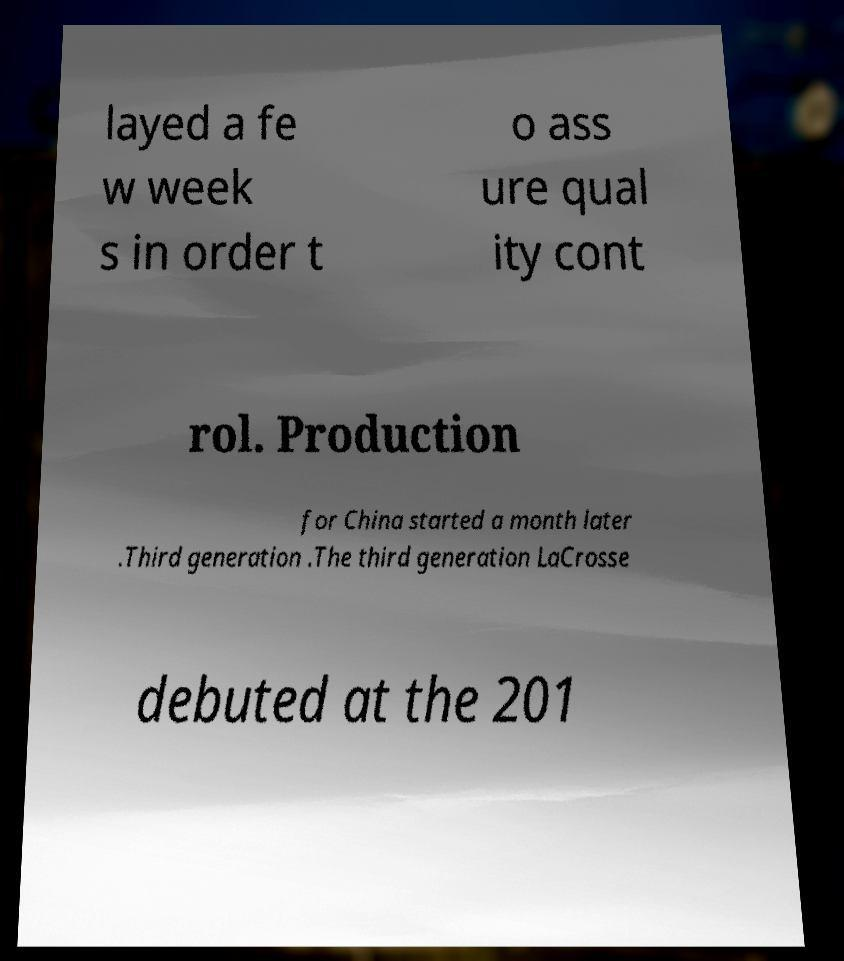Can you read and provide the text displayed in the image?This photo seems to have some interesting text. Can you extract and type it out for me? layed a fe w week s in order t o ass ure qual ity cont rol. Production for China started a month later .Third generation .The third generation LaCrosse debuted at the 201 